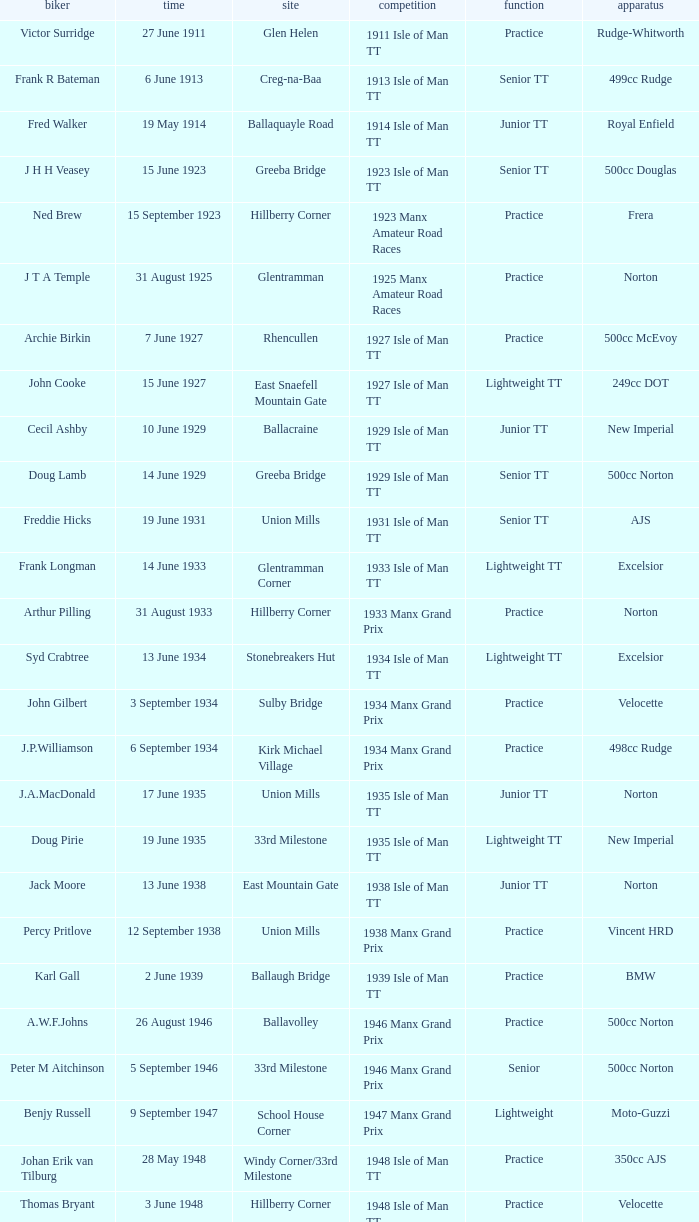What event was Rob Vine riding? Senior TT. 